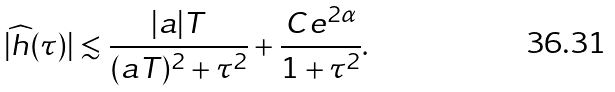Convert formula to latex. <formula><loc_0><loc_0><loc_500><loc_500>| \widehat { h } ( \tau ) | \lesssim \frac { | a | T } { ( a T ) ^ { 2 } + \tau ^ { 2 } } + \frac { C e ^ { 2 \alpha } } { 1 + \tau ^ { 2 } } .</formula> 